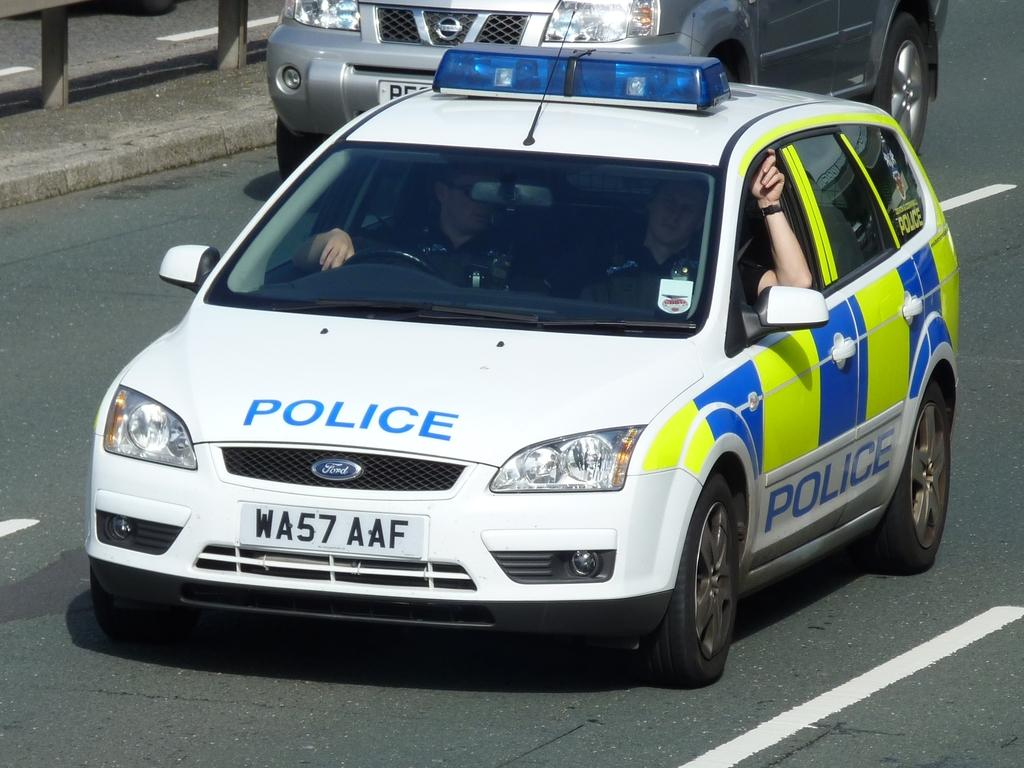What can be seen on the road in the image? There are cars on the road in the image. What are the people in the cars doing? The people are seated in the cars. What type of material is used for the rods visible in the image? The rods visible in the image are made of metal. What type of juice can be seen being poured from a bottle in the image? There is no juice or bottle present in the image. How many feet are visible in the image? There are no feet visible in the image. 